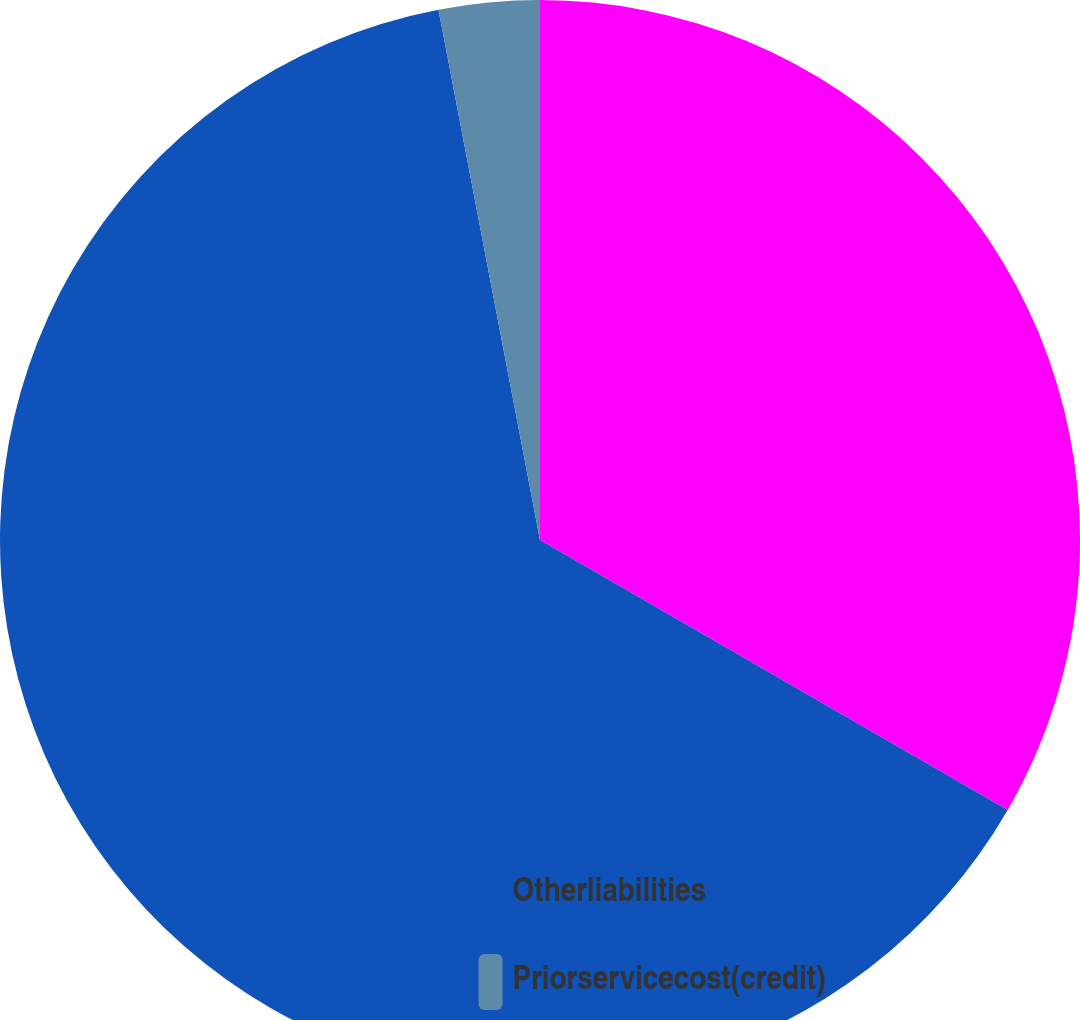Convert chart to OTSL. <chart><loc_0><loc_0><loc_500><loc_500><pie_chart><ecel><fcel>Otherliabilities<fcel>Priorservicecost(credit)<nl><fcel>33.33%<fcel>63.66%<fcel>3.01%<nl></chart> 